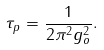<formula> <loc_0><loc_0><loc_500><loc_500>\tau _ { p } = \frac { 1 } { 2 \pi ^ { 2 } g _ { o } ^ { 2 } } .</formula> 